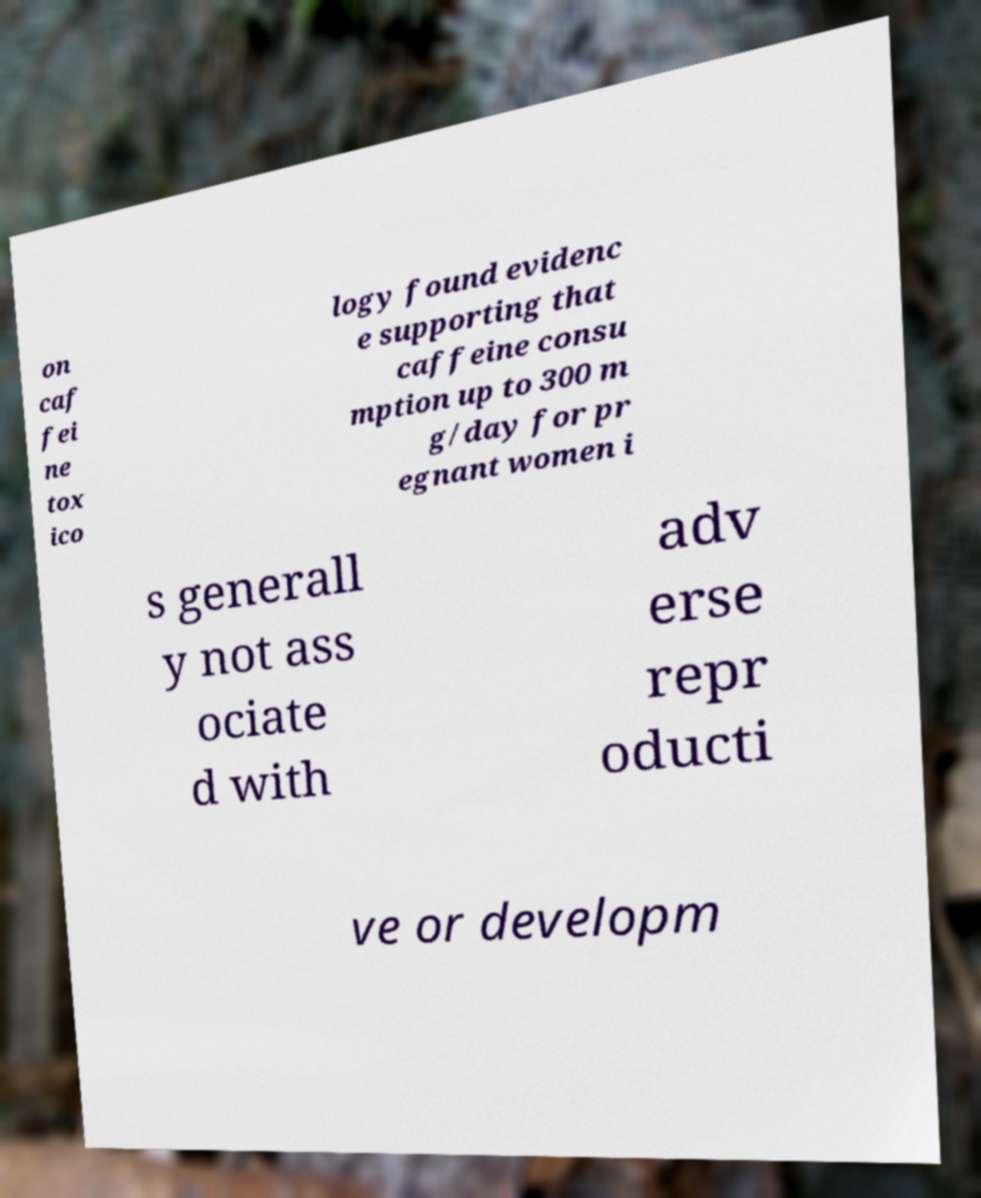There's text embedded in this image that I need extracted. Can you transcribe it verbatim? on caf fei ne tox ico logy found evidenc e supporting that caffeine consu mption up to 300 m g/day for pr egnant women i s generall y not ass ociate d with adv erse repr oducti ve or developm 